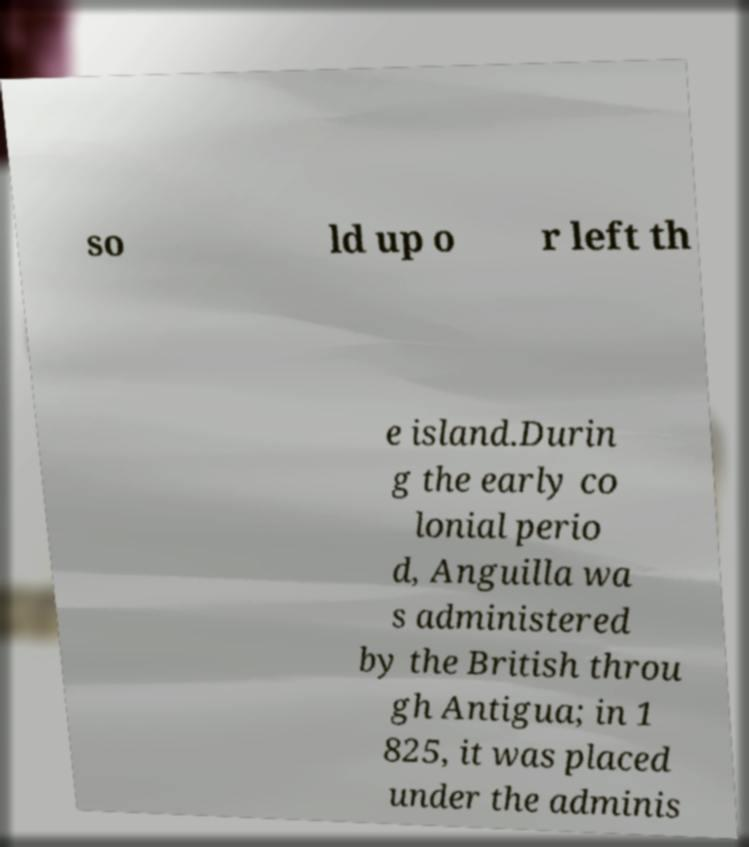Can you read and provide the text displayed in the image?This photo seems to have some interesting text. Can you extract and type it out for me? so ld up o r left th e island.Durin g the early co lonial perio d, Anguilla wa s administered by the British throu gh Antigua; in 1 825, it was placed under the adminis 